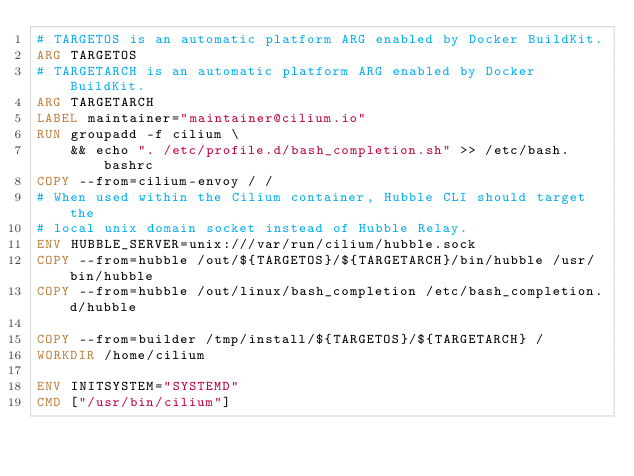Convert code to text. <code><loc_0><loc_0><loc_500><loc_500><_Dockerfile_># TARGETOS is an automatic platform ARG enabled by Docker BuildKit.
ARG TARGETOS
# TARGETARCH is an automatic platform ARG enabled by Docker BuildKit.
ARG TARGETARCH
LABEL maintainer="maintainer@cilium.io"
RUN groupadd -f cilium \
    && echo ". /etc/profile.d/bash_completion.sh" >> /etc/bash.bashrc
COPY --from=cilium-envoy / /
# When used within the Cilium container, Hubble CLI should target the
# local unix domain socket instead of Hubble Relay.
ENV HUBBLE_SERVER=unix:///var/run/cilium/hubble.sock
COPY --from=hubble /out/${TARGETOS}/${TARGETARCH}/bin/hubble /usr/bin/hubble
COPY --from=hubble /out/linux/bash_completion /etc/bash_completion.d/hubble

COPY --from=builder /tmp/install/${TARGETOS}/${TARGETARCH} /
WORKDIR /home/cilium

ENV INITSYSTEM="SYSTEMD"
CMD ["/usr/bin/cilium"]
</code> 